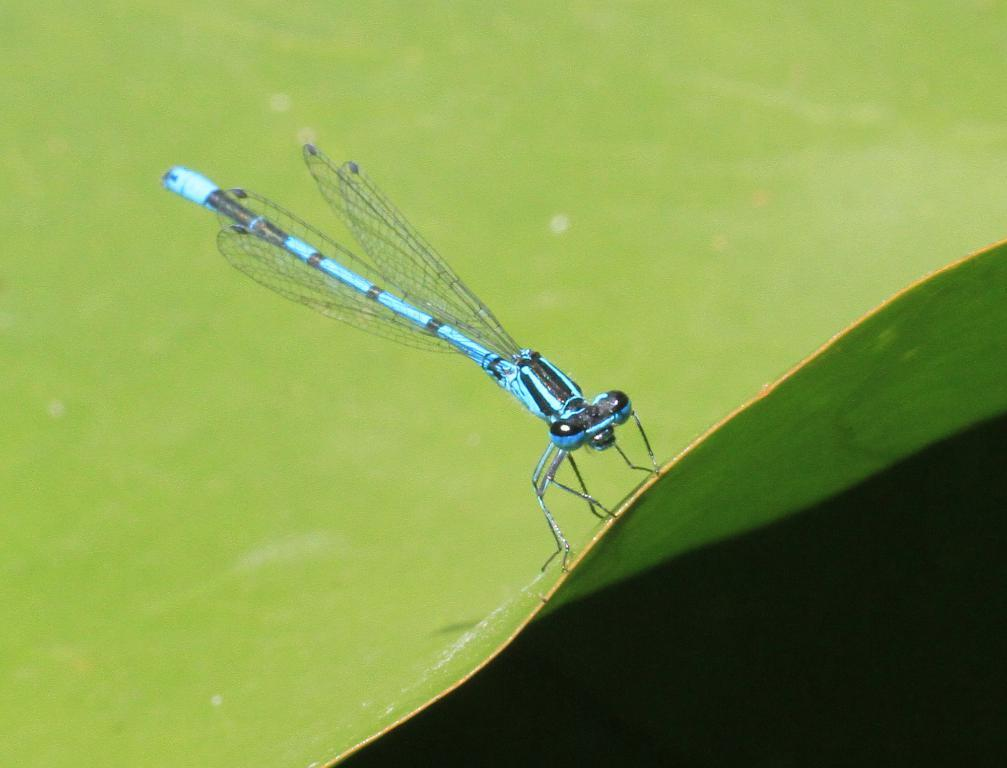What is the main subject of the image? The main subject of the image is a dragonfly. Where is the dragonfly located in the image? The dragonfly is in the center of the image. What is the dragonfly resting on in the image? The dragonfly is on a green color object. How many bushes are surrounding the dragonfly in the image? There is no mention of bushes in the image; it only features a dragonfly on a green color object. Are there any brothers or girls visible in the image? There is no mention of brothers or girls in the image; it only features a dragonfly on a green color object. 